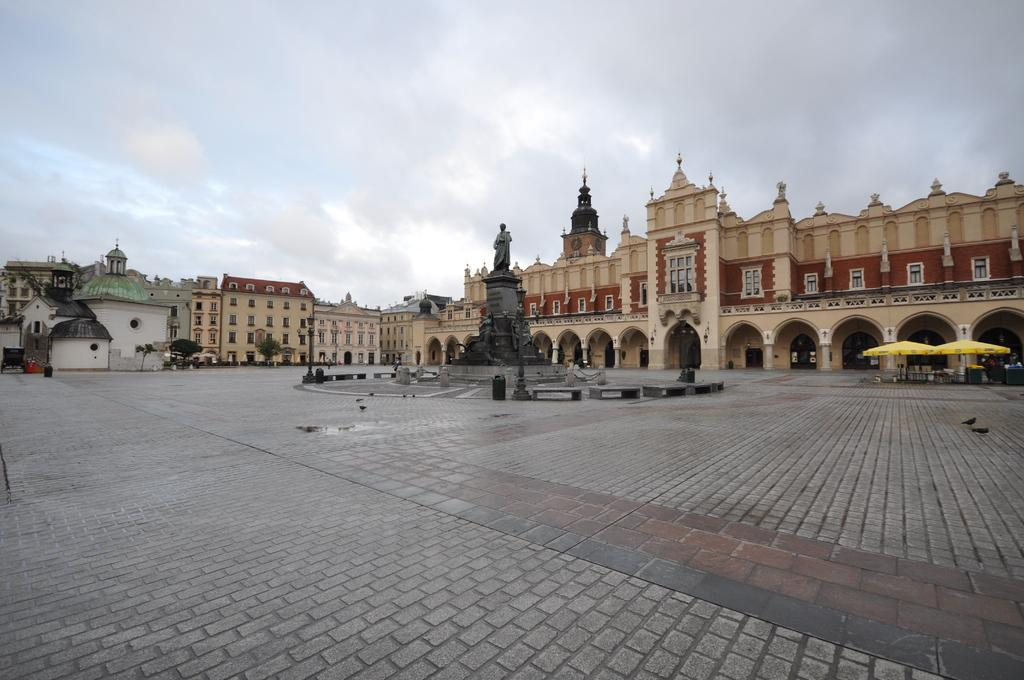What is the main subject in the image? There is a statue of a person in the image. What can be seen to the right of the statue? There are tents to the right of the statue. What is visible in the background of the image? There are many buildings and trees in the background of the image. What is the condition of the sky in the image? Clouds are visible in the sky, and the sky is visible in the image. What flavor of ice cream is being served in the room in the image? There is no room or ice cream present in the image; it features a statue, tents, buildings, trees, and a sky with clouds. 